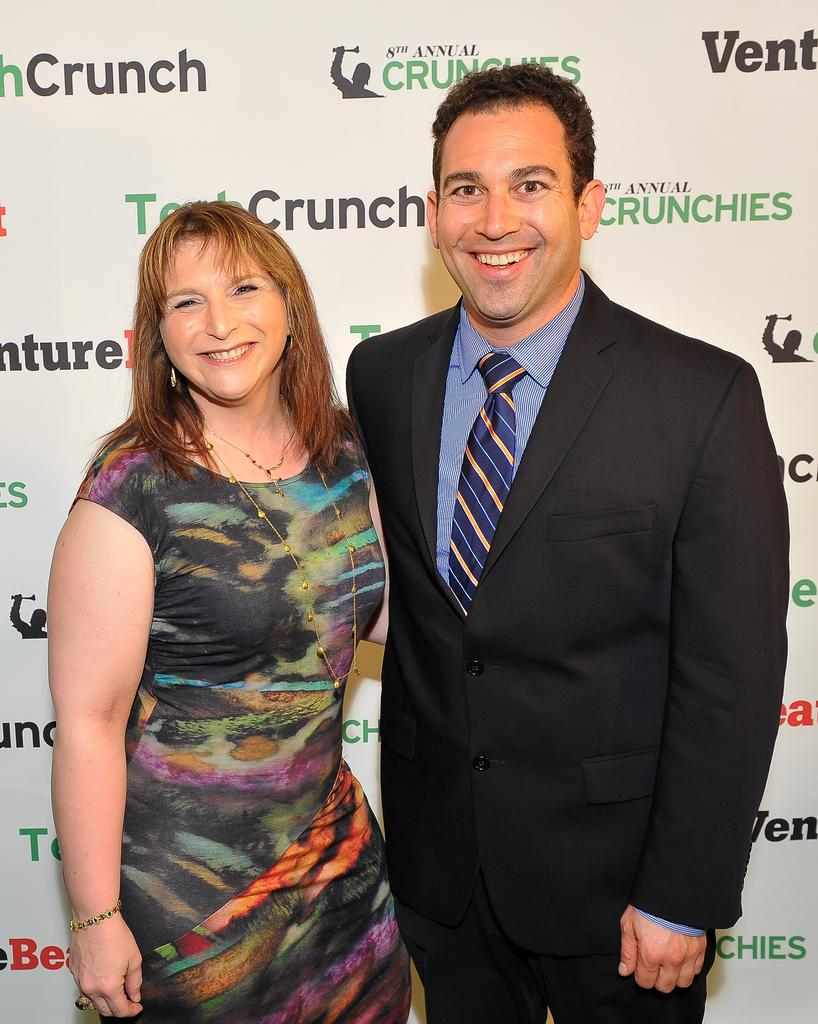Who is present in the image? There is a man and a woman in the image. What is the man wearing? The man is wearing a suit. What are the man and woman standing near? They are standing near a banner. What type of honey can be seen dripping from the coat of the man in the image? There is no honey or coat present in the image. Is there a cemetery visible in the background of the image? There is no mention of a cemetery in the provided facts, and therefore it cannot be determined if one is visible in the image. 